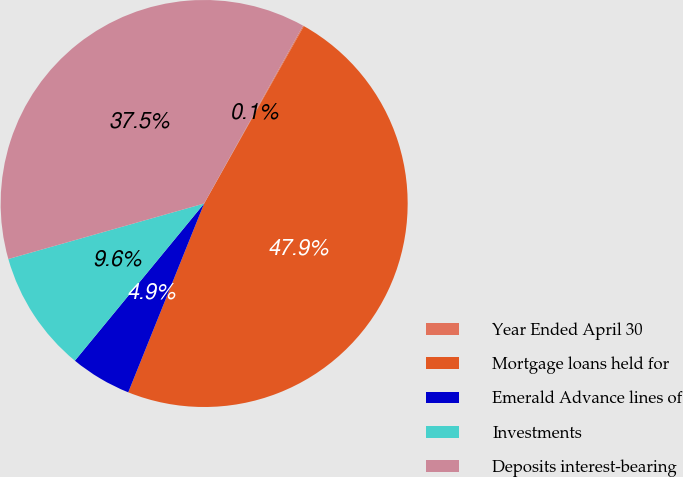Convert chart. <chart><loc_0><loc_0><loc_500><loc_500><pie_chart><fcel>Year Ended April 30<fcel>Mortgage loans held for<fcel>Emerald Advance lines of<fcel>Investments<fcel>Deposits interest-bearing<nl><fcel>0.08%<fcel>47.93%<fcel>4.87%<fcel>9.65%<fcel>37.47%<nl></chart> 